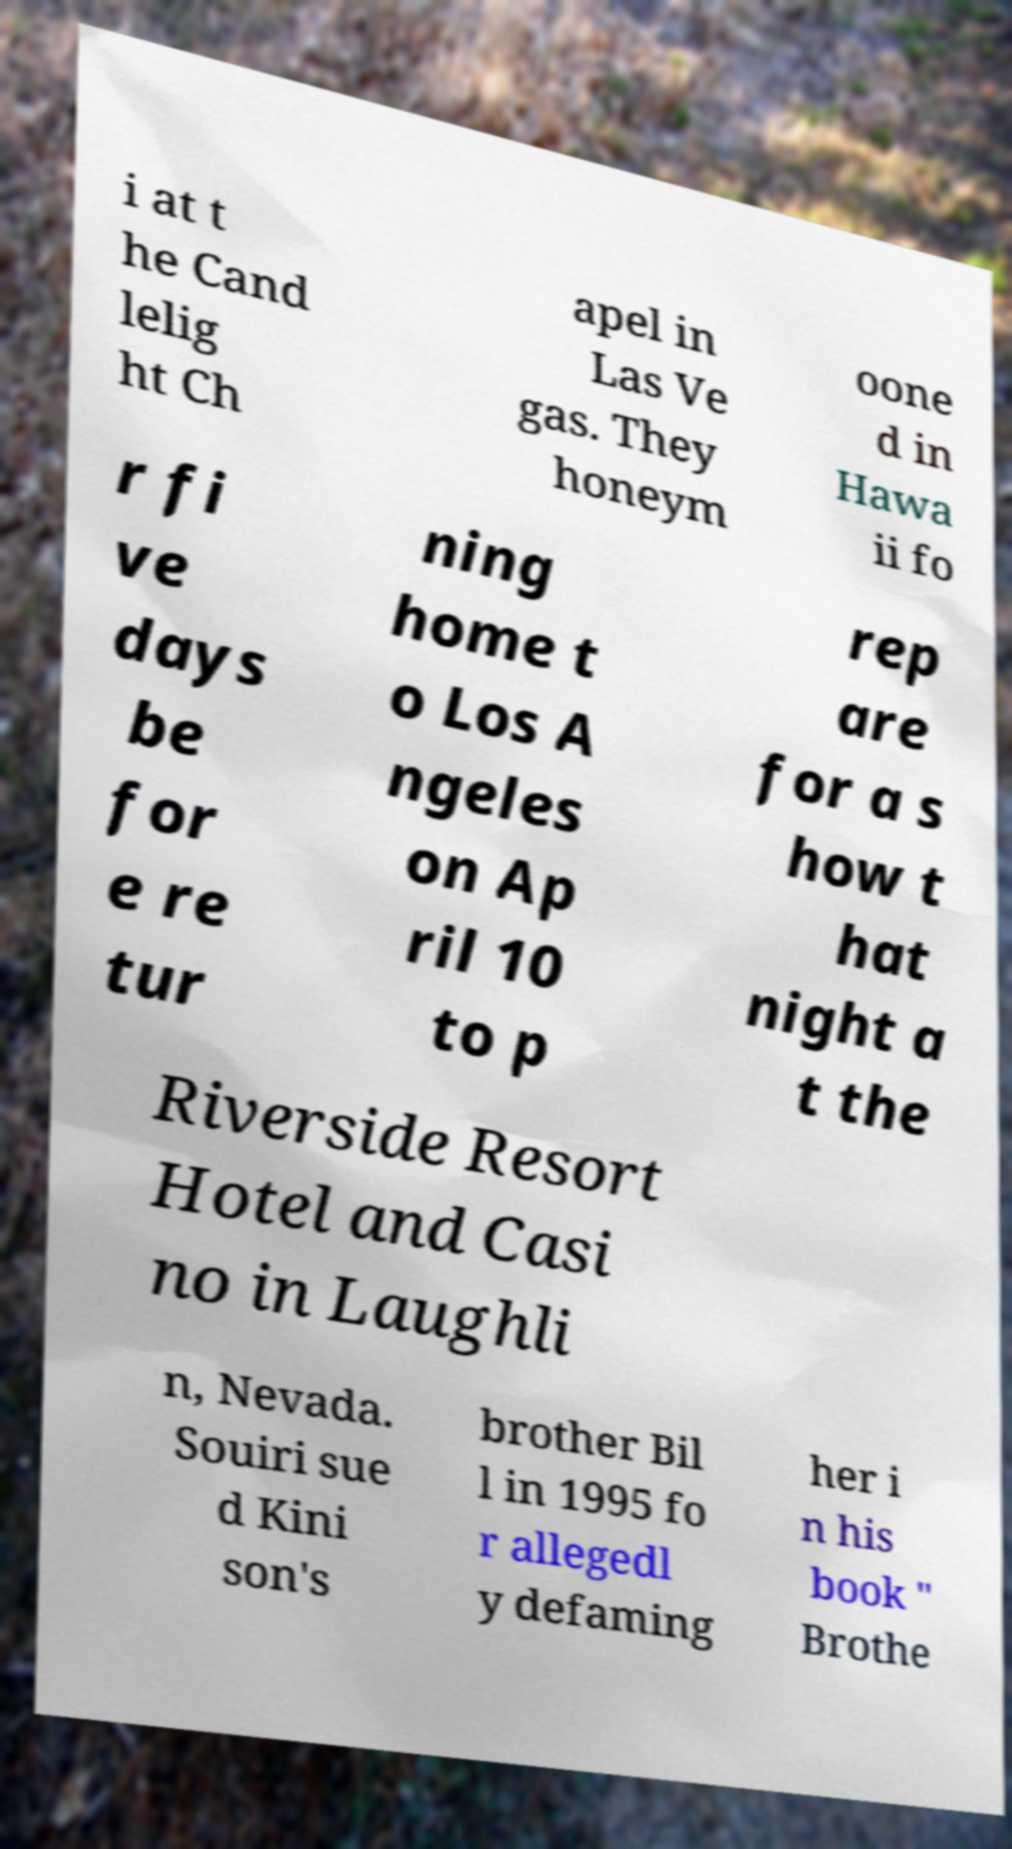Could you assist in decoding the text presented in this image and type it out clearly? i at t he Cand lelig ht Ch apel in Las Ve gas. They honeym oone d in Hawa ii fo r fi ve days be for e re tur ning home t o Los A ngeles on Ap ril 10 to p rep are for a s how t hat night a t the Riverside Resort Hotel and Casi no in Laughli n, Nevada. Souiri sue d Kini son's brother Bil l in 1995 fo r allegedl y defaming her i n his book " Brothe 